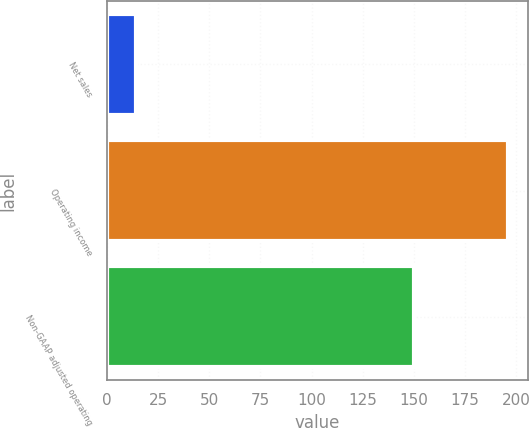Convert chart. <chart><loc_0><loc_0><loc_500><loc_500><bar_chart><fcel>Net sales<fcel>Operating income<fcel>Non-GAAP adjusted operating<nl><fcel>14<fcel>196<fcel>150<nl></chart> 